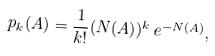<formula> <loc_0><loc_0><loc_500><loc_500>p _ { k } ( A ) = \frac { 1 } { k ! } ( N ( A ) ) ^ { k } \, e ^ { - N ( A ) } ,</formula> 